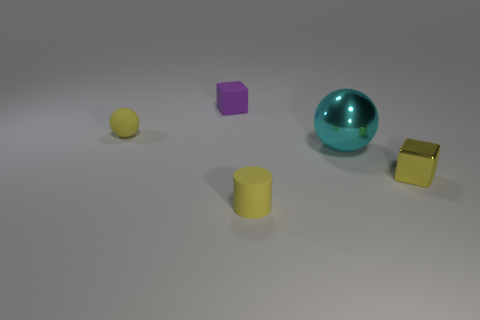Add 2 big blue metallic blocks. How many objects exist? 7 Subtract all cylinders. How many objects are left? 4 Subtract 0 gray cylinders. How many objects are left? 5 Subtract all purple matte blocks. Subtract all large purple blocks. How many objects are left? 4 Add 5 large cyan metallic objects. How many large cyan metallic objects are left? 6 Add 4 cyan metal objects. How many cyan metal objects exist? 5 